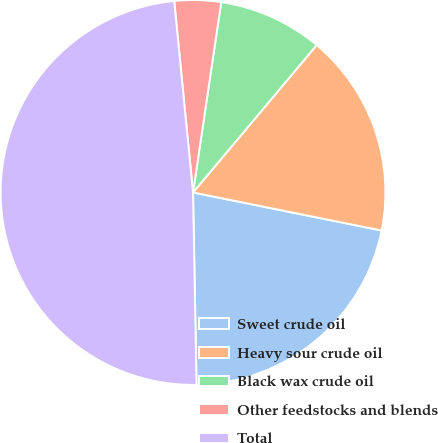Convert chart. <chart><loc_0><loc_0><loc_500><loc_500><pie_chart><fcel>Sweet crude oil<fcel>Heavy sour crude oil<fcel>Black wax crude oil<fcel>Other feedstocks and blends<fcel>Total<nl><fcel>21.54%<fcel>17.06%<fcel>8.77%<fcel>3.9%<fcel>48.73%<nl></chart> 